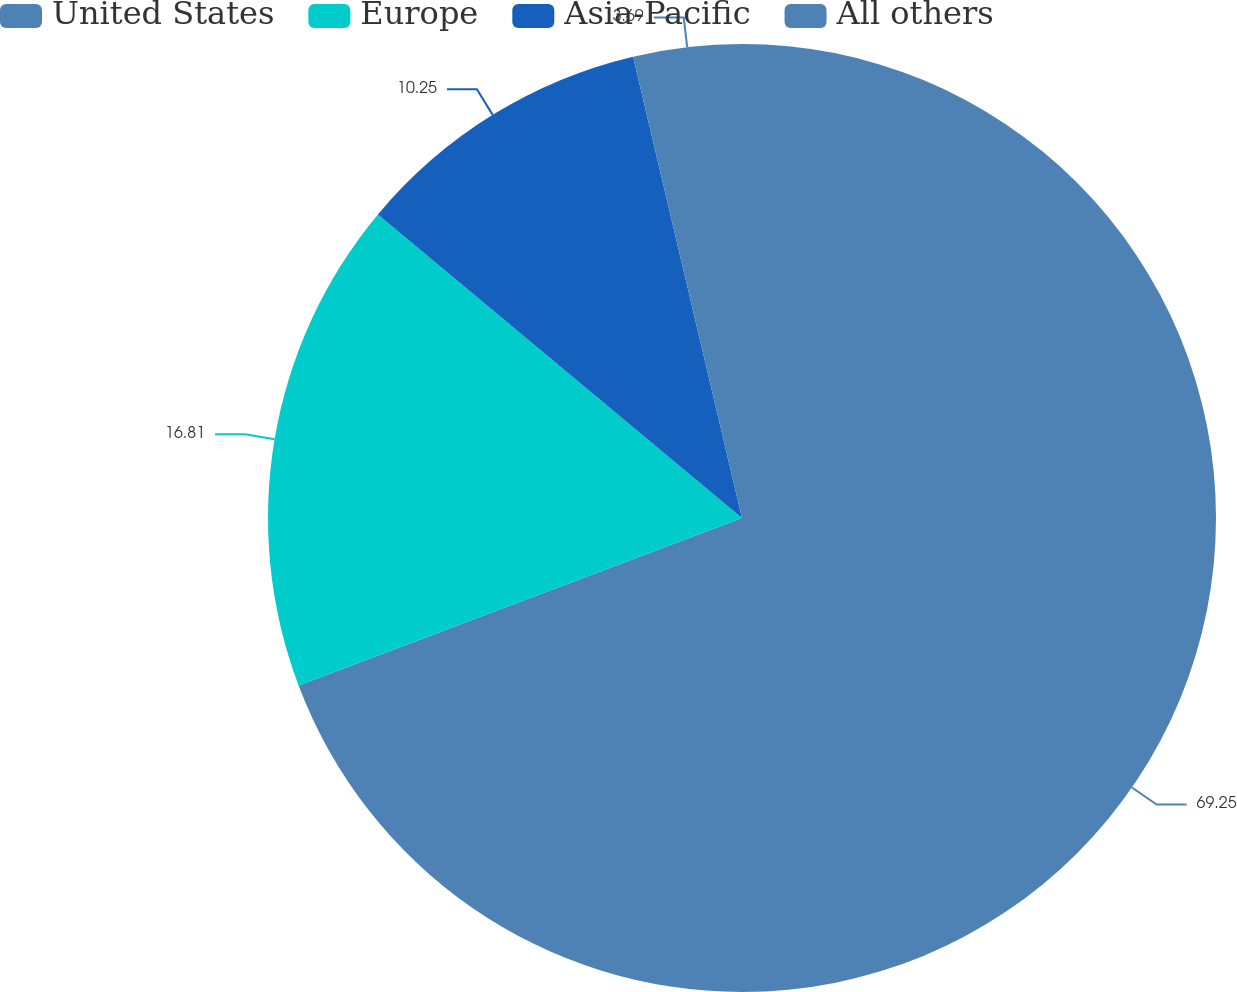<chart> <loc_0><loc_0><loc_500><loc_500><pie_chart><fcel>United States<fcel>Europe<fcel>Asia-Pacific<fcel>All others<nl><fcel>69.25%<fcel>16.81%<fcel>10.25%<fcel>3.69%<nl></chart> 